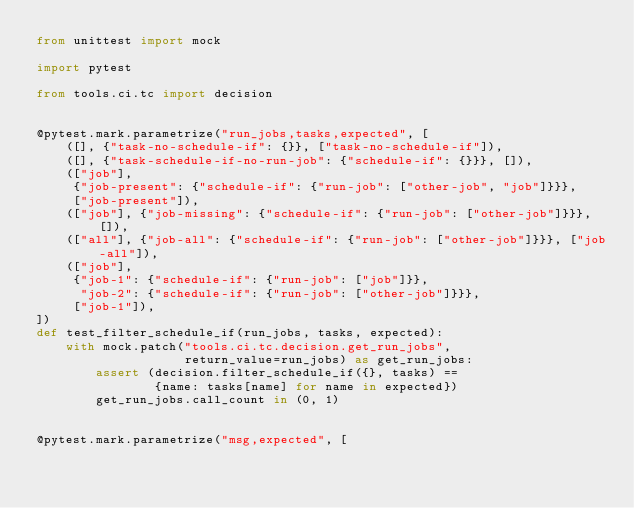Convert code to text. <code><loc_0><loc_0><loc_500><loc_500><_Python_>from unittest import mock

import pytest

from tools.ci.tc import decision


@pytest.mark.parametrize("run_jobs,tasks,expected", [
    ([], {"task-no-schedule-if": {}}, ["task-no-schedule-if"]),
    ([], {"task-schedule-if-no-run-job": {"schedule-if": {}}}, []),
    (["job"],
     {"job-present": {"schedule-if": {"run-job": ["other-job", "job"]}}},
     ["job-present"]),
    (["job"], {"job-missing": {"schedule-if": {"run-job": ["other-job"]}}}, []),
    (["all"], {"job-all": {"schedule-if": {"run-job": ["other-job"]}}}, ["job-all"]),
    (["job"],
     {"job-1": {"schedule-if": {"run-job": ["job"]}},
      "job-2": {"schedule-if": {"run-job": ["other-job"]}}},
     ["job-1"]),
])
def test_filter_schedule_if(run_jobs, tasks, expected):
    with mock.patch("tools.ci.tc.decision.get_run_jobs",
                    return_value=run_jobs) as get_run_jobs:
        assert (decision.filter_schedule_if({}, tasks) ==
                {name: tasks[name] for name in expected})
        get_run_jobs.call_count in (0, 1)


@pytest.mark.parametrize("msg,expected", [</code> 